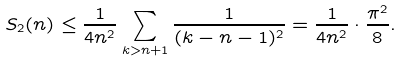<formula> <loc_0><loc_0><loc_500><loc_500>S _ { 2 } ( n ) \leq \frac { 1 } { 4 n ^ { 2 } } \sum _ { k > n + 1 } \frac { 1 } { ( k - n - 1 ) ^ { 2 } } = \frac { 1 } { 4 n ^ { 2 } } \cdot \frac { \pi ^ { 2 } } { 8 } .</formula> 